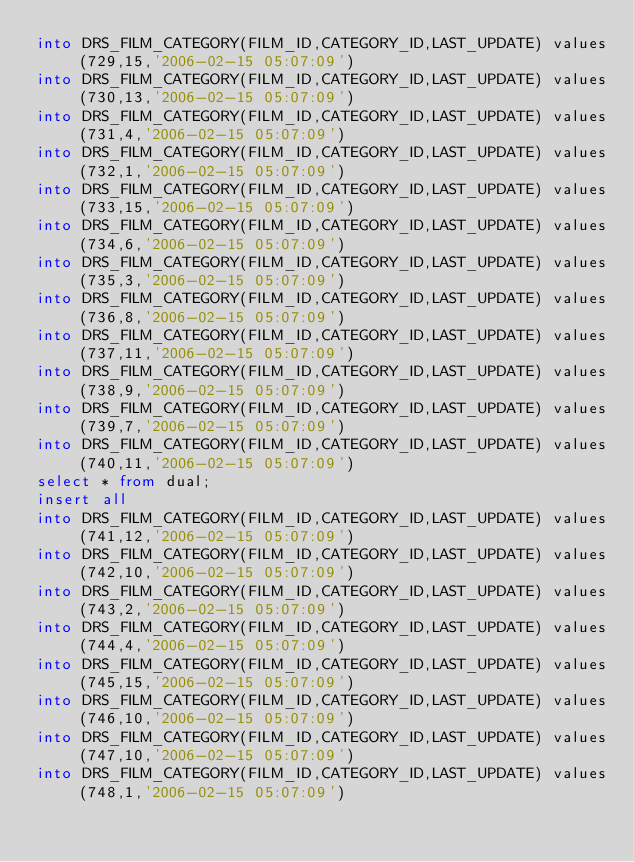Convert code to text. <code><loc_0><loc_0><loc_500><loc_500><_SQL_>into DRS_FILM_CATEGORY(FILM_ID,CATEGORY_ID,LAST_UPDATE) values (729,15,'2006-02-15 05:07:09')
into DRS_FILM_CATEGORY(FILM_ID,CATEGORY_ID,LAST_UPDATE) values (730,13,'2006-02-15 05:07:09')
into DRS_FILM_CATEGORY(FILM_ID,CATEGORY_ID,LAST_UPDATE) values (731,4,'2006-02-15 05:07:09')
into DRS_FILM_CATEGORY(FILM_ID,CATEGORY_ID,LAST_UPDATE) values (732,1,'2006-02-15 05:07:09')
into DRS_FILM_CATEGORY(FILM_ID,CATEGORY_ID,LAST_UPDATE) values (733,15,'2006-02-15 05:07:09')
into DRS_FILM_CATEGORY(FILM_ID,CATEGORY_ID,LAST_UPDATE) values (734,6,'2006-02-15 05:07:09')
into DRS_FILM_CATEGORY(FILM_ID,CATEGORY_ID,LAST_UPDATE) values (735,3,'2006-02-15 05:07:09')
into DRS_FILM_CATEGORY(FILM_ID,CATEGORY_ID,LAST_UPDATE) values (736,8,'2006-02-15 05:07:09')
into DRS_FILM_CATEGORY(FILM_ID,CATEGORY_ID,LAST_UPDATE) values (737,11,'2006-02-15 05:07:09')
into DRS_FILM_CATEGORY(FILM_ID,CATEGORY_ID,LAST_UPDATE) values (738,9,'2006-02-15 05:07:09')
into DRS_FILM_CATEGORY(FILM_ID,CATEGORY_ID,LAST_UPDATE) values (739,7,'2006-02-15 05:07:09')
into DRS_FILM_CATEGORY(FILM_ID,CATEGORY_ID,LAST_UPDATE) values (740,11,'2006-02-15 05:07:09')
select * from dual;
insert all
into DRS_FILM_CATEGORY(FILM_ID,CATEGORY_ID,LAST_UPDATE) values (741,12,'2006-02-15 05:07:09')
into DRS_FILM_CATEGORY(FILM_ID,CATEGORY_ID,LAST_UPDATE) values (742,10,'2006-02-15 05:07:09')
into DRS_FILM_CATEGORY(FILM_ID,CATEGORY_ID,LAST_UPDATE) values (743,2,'2006-02-15 05:07:09')
into DRS_FILM_CATEGORY(FILM_ID,CATEGORY_ID,LAST_UPDATE) values (744,4,'2006-02-15 05:07:09')
into DRS_FILM_CATEGORY(FILM_ID,CATEGORY_ID,LAST_UPDATE) values (745,15,'2006-02-15 05:07:09')
into DRS_FILM_CATEGORY(FILM_ID,CATEGORY_ID,LAST_UPDATE) values (746,10,'2006-02-15 05:07:09')
into DRS_FILM_CATEGORY(FILM_ID,CATEGORY_ID,LAST_UPDATE) values (747,10,'2006-02-15 05:07:09')
into DRS_FILM_CATEGORY(FILM_ID,CATEGORY_ID,LAST_UPDATE) values (748,1,'2006-02-15 05:07:09')</code> 